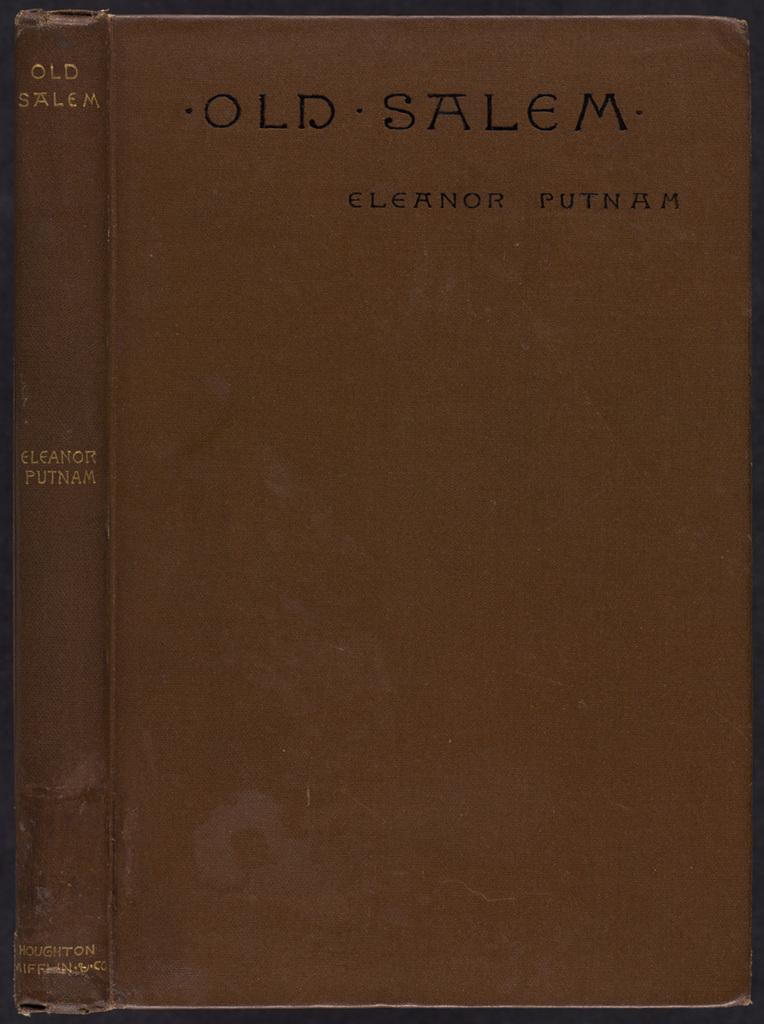<image>
Offer a succinct explanation of the picture presented. Front of an old red hardback book Old Salem by Eleanor Putman 